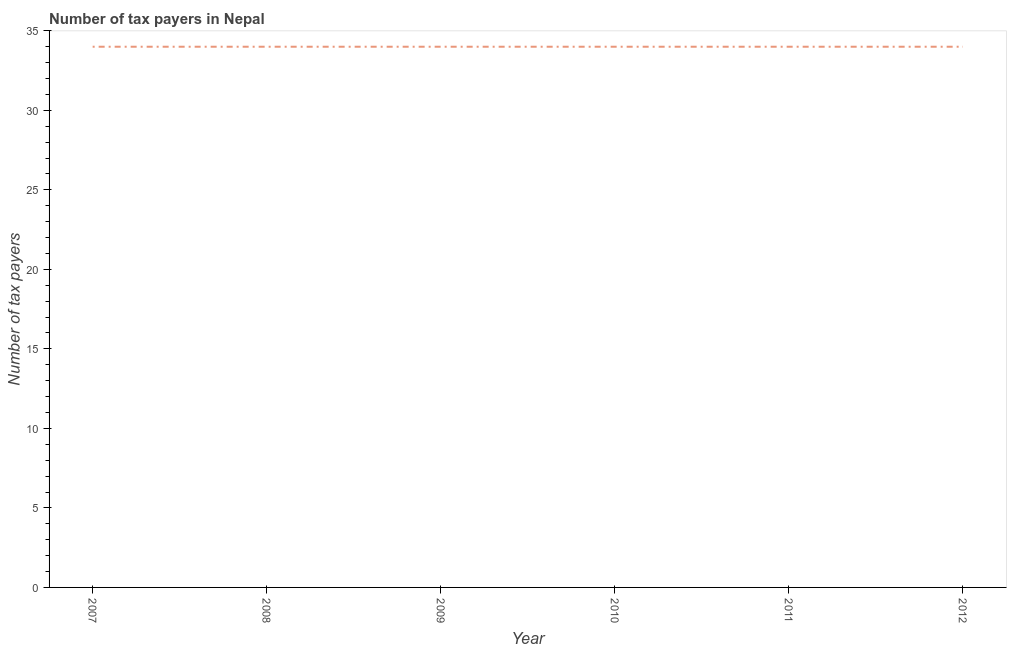What is the number of tax payers in 2012?
Keep it short and to the point. 34. Across all years, what is the maximum number of tax payers?
Your response must be concise. 34. Across all years, what is the minimum number of tax payers?
Your response must be concise. 34. In which year was the number of tax payers maximum?
Offer a terse response. 2007. In which year was the number of tax payers minimum?
Provide a short and direct response. 2007. What is the sum of the number of tax payers?
Offer a very short reply. 204. What is the difference between the number of tax payers in 2007 and 2012?
Offer a very short reply. 0. What is the average number of tax payers per year?
Your response must be concise. 34. What is the median number of tax payers?
Your answer should be very brief. 34. In how many years, is the number of tax payers greater than 8 ?
Your response must be concise. 6. Do a majority of the years between 2012 and 2008 (inclusive) have number of tax payers greater than 30 ?
Your response must be concise. Yes. Is the number of tax payers in 2010 less than that in 2012?
Provide a short and direct response. No. Is the difference between the number of tax payers in 2007 and 2010 greater than the difference between any two years?
Provide a succinct answer. Yes. What is the difference between the highest and the second highest number of tax payers?
Ensure brevity in your answer.  0. Is the sum of the number of tax payers in 2011 and 2012 greater than the maximum number of tax payers across all years?
Provide a succinct answer. Yes. What is the difference between the highest and the lowest number of tax payers?
Offer a very short reply. 0. In how many years, is the number of tax payers greater than the average number of tax payers taken over all years?
Your answer should be very brief. 0. Does the number of tax payers monotonically increase over the years?
Ensure brevity in your answer.  No. How many lines are there?
Your answer should be compact. 1. How many years are there in the graph?
Your answer should be very brief. 6. Does the graph contain grids?
Ensure brevity in your answer.  No. What is the title of the graph?
Your answer should be very brief. Number of tax payers in Nepal. What is the label or title of the X-axis?
Your answer should be compact. Year. What is the label or title of the Y-axis?
Provide a succinct answer. Number of tax payers. What is the Number of tax payers of 2008?
Make the answer very short. 34. What is the Number of tax payers in 2011?
Your answer should be very brief. 34. What is the Number of tax payers in 2012?
Your answer should be compact. 34. What is the difference between the Number of tax payers in 2007 and 2012?
Your answer should be very brief. 0. What is the difference between the Number of tax payers in 2008 and 2009?
Offer a very short reply. 0. What is the difference between the Number of tax payers in 2008 and 2010?
Keep it short and to the point. 0. What is the difference between the Number of tax payers in 2008 and 2011?
Give a very brief answer. 0. What is the difference between the Number of tax payers in 2009 and 2010?
Offer a very short reply. 0. What is the difference between the Number of tax payers in 2010 and 2012?
Your answer should be compact. 0. What is the difference between the Number of tax payers in 2011 and 2012?
Your response must be concise. 0. What is the ratio of the Number of tax payers in 2007 to that in 2008?
Keep it short and to the point. 1. What is the ratio of the Number of tax payers in 2007 to that in 2009?
Your answer should be very brief. 1. What is the ratio of the Number of tax payers in 2007 to that in 2012?
Ensure brevity in your answer.  1. What is the ratio of the Number of tax payers in 2008 to that in 2012?
Your answer should be very brief. 1. What is the ratio of the Number of tax payers in 2009 to that in 2011?
Offer a terse response. 1. What is the ratio of the Number of tax payers in 2010 to that in 2012?
Offer a very short reply. 1. What is the ratio of the Number of tax payers in 2011 to that in 2012?
Offer a very short reply. 1. 